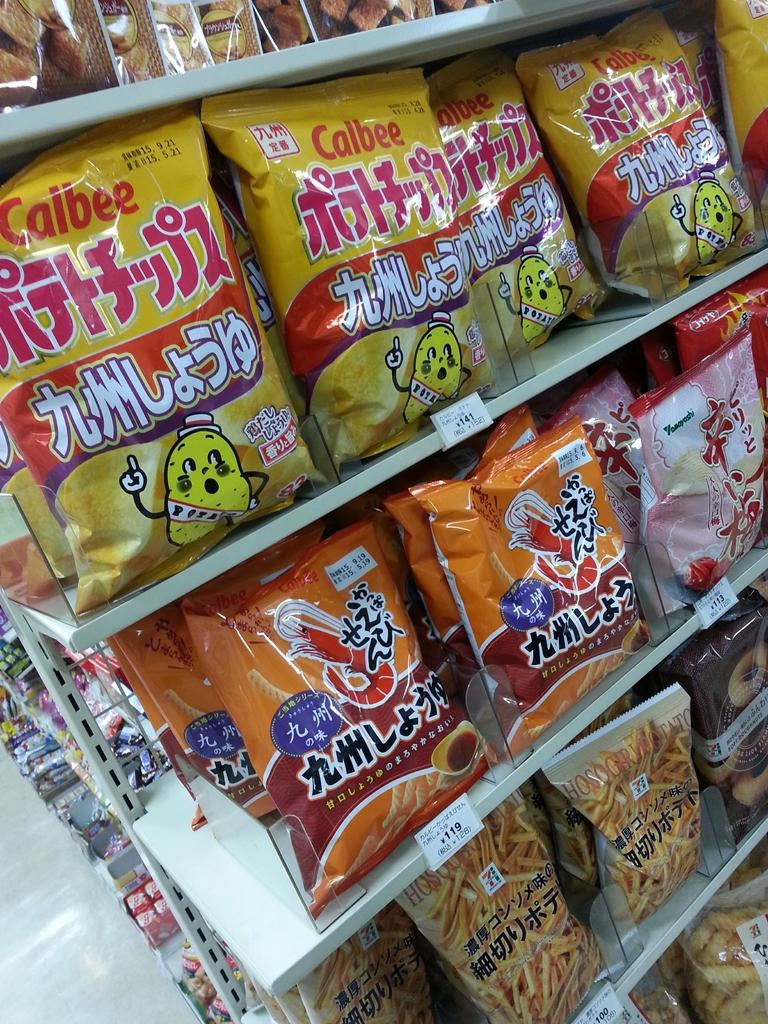What is located in the foreground of the image? There are products on a shelf in the foreground of the image. What else can be seen in the image besides the products on the shelf? There are products visible in the background of the image. What part of the store or room can be seen in the background of the image? The floor is visible in the background of the image. How many houses are visible in the image? There are no houses visible in the image; it features products on a shelf and the floor in the background. 